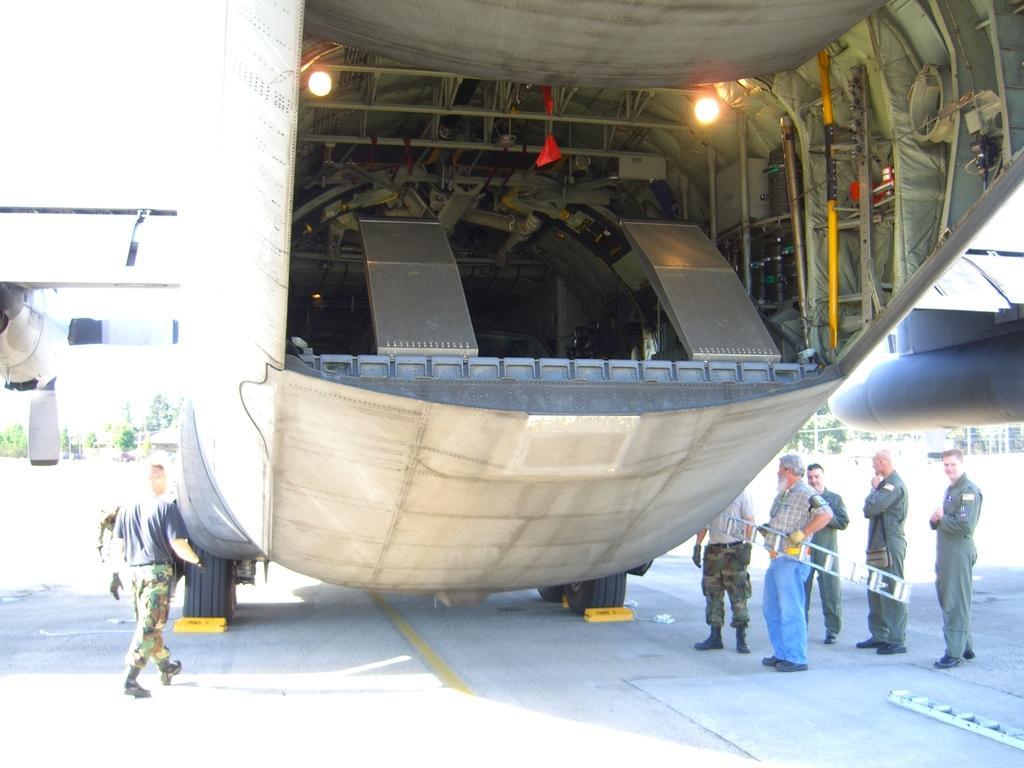How would you summarize this image in a sentence or two? In this image we can see a motor vehicle on the road, person's standing on the road and one of them is holding a ladder in the hands, trees and sky. 